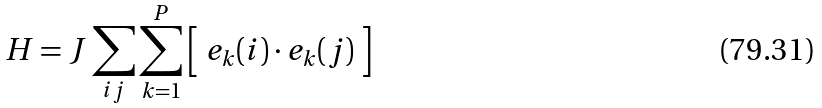<formula> <loc_0><loc_0><loc_500><loc_500>H = J \sum _ { i j } \sum _ { k = 1 } ^ { P } \Big { [ } \ { e } _ { k } ( i ) \cdot { e } _ { k } ( j ) \ \Big { ] }</formula> 